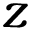Convert formula to latex. <formula><loc_0><loc_0><loc_500><loc_500>z</formula> 